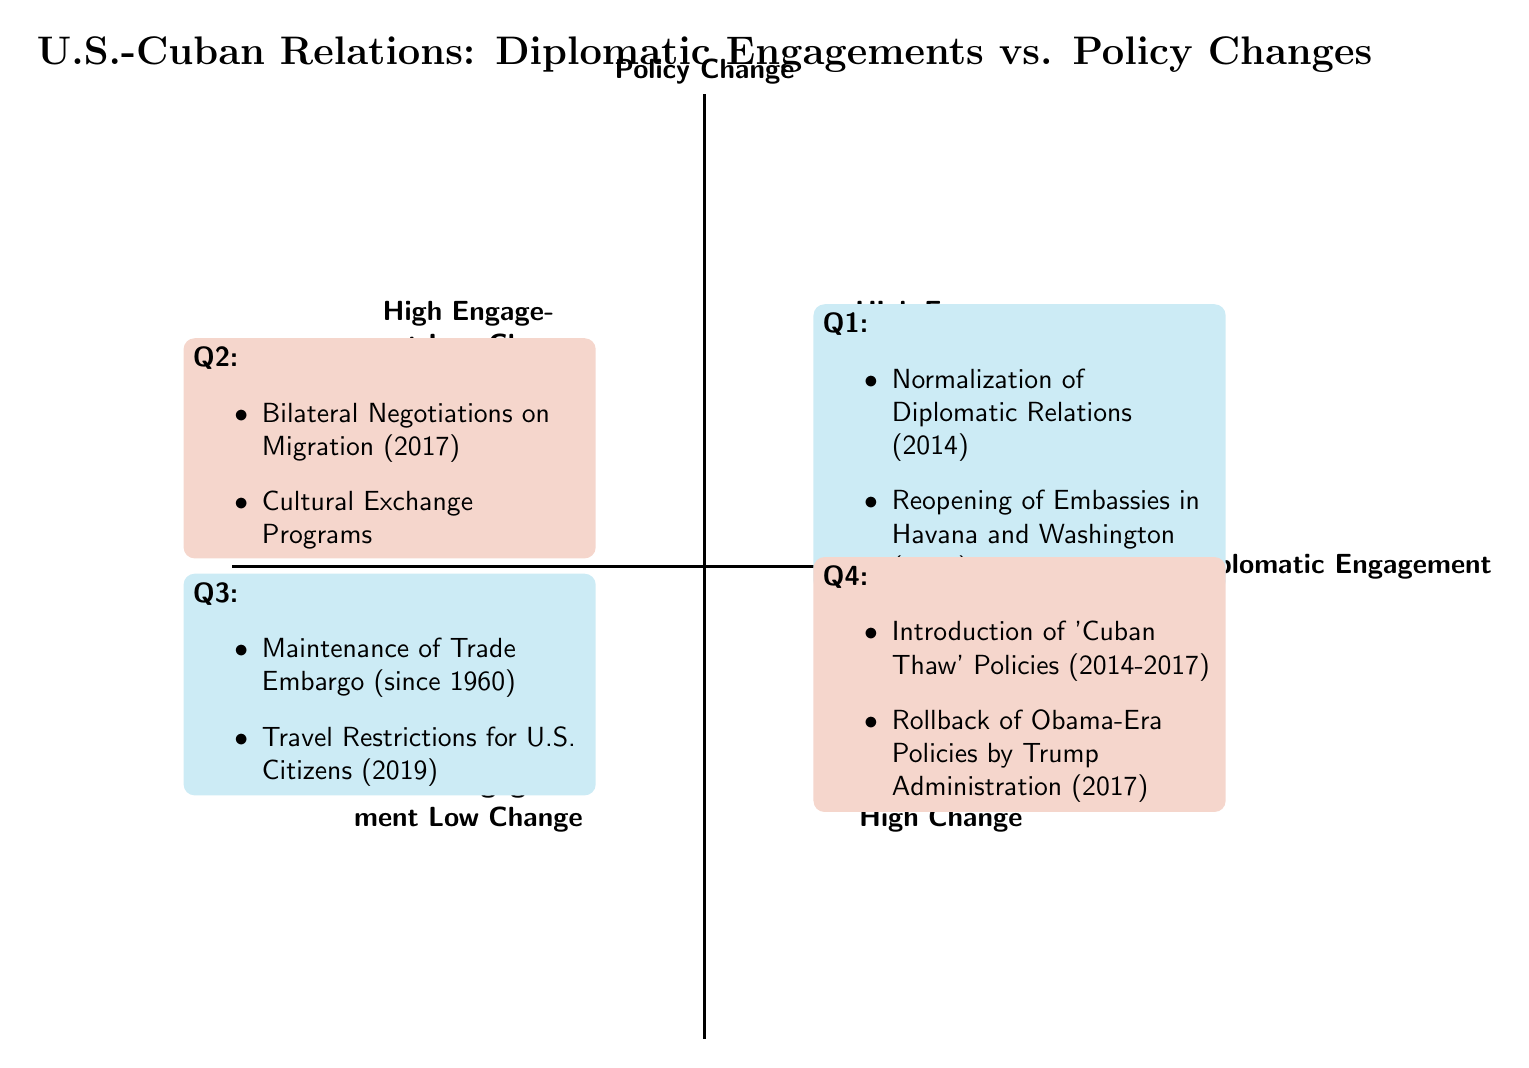What elements are included in Q1? Q1 is labeled "High Engagement High Change." The elements listed under this quadrant are "Normalization of Diplomatic Relations (2014)" and "Reopening of Embassies in Havana and Washington (2015)."
Answer: Normalization of Diplomatic Relations (2014), Reopening of Embassies in Havana and Washington (2015) How many total elements are there in the chart? Each of the four quadrants contains a certain number of elements: Q1 has 2, Q2 has 2, Q3 has 2, and Q4 has 2. Adding these together gives a total of 2 + 2 + 2 + 2 = 8 elements in the chart.
Answer: 8 Which quadrant contains the Rollback of Obama-Era Policies by Trump Administration? The element "Rollback of Obama-Era Policies by Trump Administration (2017)" is listed under Q4, which is labeled "Low Engagement High Change."
Answer: Q4 What quadrant has High Diplomatic Engagement but Low Policy Change? Q2 is labeled "High Engagement Low Change," which indicates it contains elements that have high levels of diplomatic engagement but low levels of policy change.
Answer: Q2 Which policy change occurred in 2014 and is featured in Q1? The policy change that occurred in 2014 and is featured in Q1 is "Normalization of Diplomatic Relations."
Answer: Normalization of Diplomatic Relations What trend do the elements in Q3 illustrate regarding U.S.-Cuban relations? The elements in Q3, such as "Maintenance of Trade Embargo (since 1960)" and "Travel Restrictions for U.S. Citizens (2019)," illustrate a trend of low diplomatic engagement and low policy change over a long period.
Answer: Low engagement and low change In which quadrant would you find Cultural Exchange Programs? Cultural Exchange Programs are found in Q2, which is characterized by High Diplomatic Engagement and Low Policy Change.
Answer: Q2 What is a notable policy change that occurred between 2014 and 2017? A notable policy change that occurred between 2014 and 2017 is the "Introduction of 'Cuban Thaw' Policies," which was aimed at enhancing diplomatic relations.
Answer: Introduction of 'Cuban Thaw' Policies 